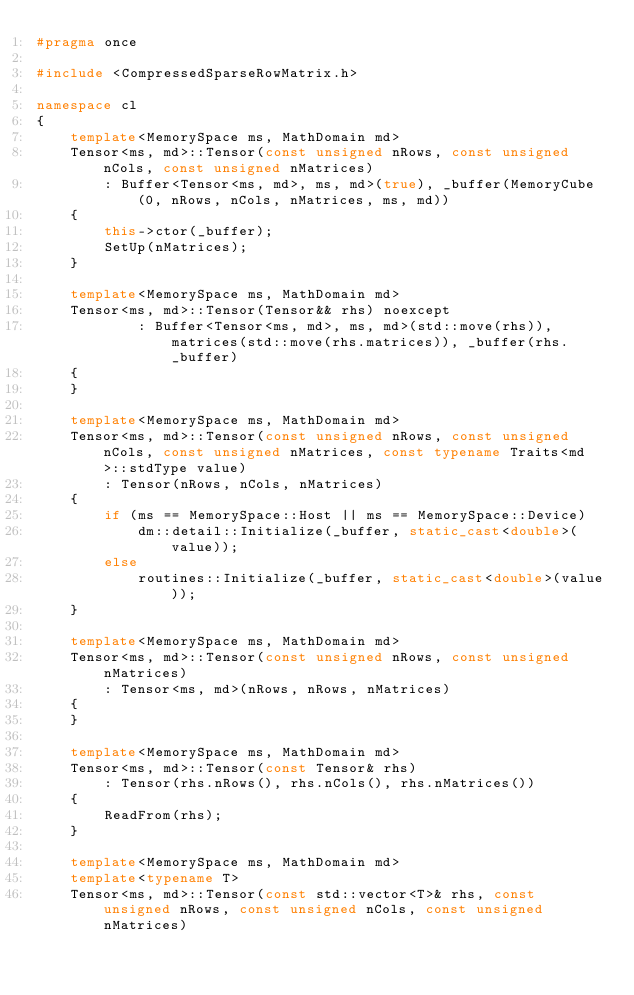<code> <loc_0><loc_0><loc_500><loc_500><_C++_>#pragma once

#include <CompressedSparseRowMatrix.h>

namespace cl
{
	template<MemorySpace ms, MathDomain md>
	Tensor<ms, md>::Tensor(const unsigned nRows, const unsigned nCols, const unsigned nMatrices)
		: Buffer<Tensor<ms, md>, ms, md>(true), _buffer(MemoryCube(0, nRows, nCols, nMatrices, ms, md))
	{
		this->ctor(_buffer);
		SetUp(nMatrices);
	}
	
	template<MemorySpace ms, MathDomain md>
	Tensor<ms, md>::Tensor(Tensor&& rhs) noexcept
			: Buffer<Tensor<ms, md>, ms, md>(std::move(rhs)), matrices(std::move(rhs.matrices)), _buffer(rhs._buffer)
	{
	}

	template<MemorySpace ms, MathDomain md>
	Tensor<ms, md>::Tensor(const unsigned nRows, const unsigned nCols, const unsigned nMatrices, const typename Traits<md>::stdType value)
		: Tensor(nRows, nCols, nMatrices)
	{
		if (ms == MemorySpace::Host || ms == MemorySpace::Device)
			dm::detail::Initialize(_buffer, static_cast<double>(value));
		else
			routines::Initialize(_buffer, static_cast<double>(value));
	}

	template<MemorySpace ms, MathDomain md>
	Tensor<ms, md>::Tensor(const unsigned nRows, const unsigned nMatrices)
		: Tensor<ms, md>(nRows, nRows, nMatrices)
	{
	}

	template<MemorySpace ms, MathDomain md>
	Tensor<ms, md>::Tensor(const Tensor& rhs)
		: Tensor(rhs.nRows(), rhs.nCols(), rhs.nMatrices())
	{
		ReadFrom(rhs);
	}

	template<MemorySpace ms, MathDomain md>
	template<typename T>
	Tensor<ms, md>::Tensor(const std::vector<T>& rhs, const unsigned nRows, const unsigned nCols, const unsigned nMatrices)</code> 